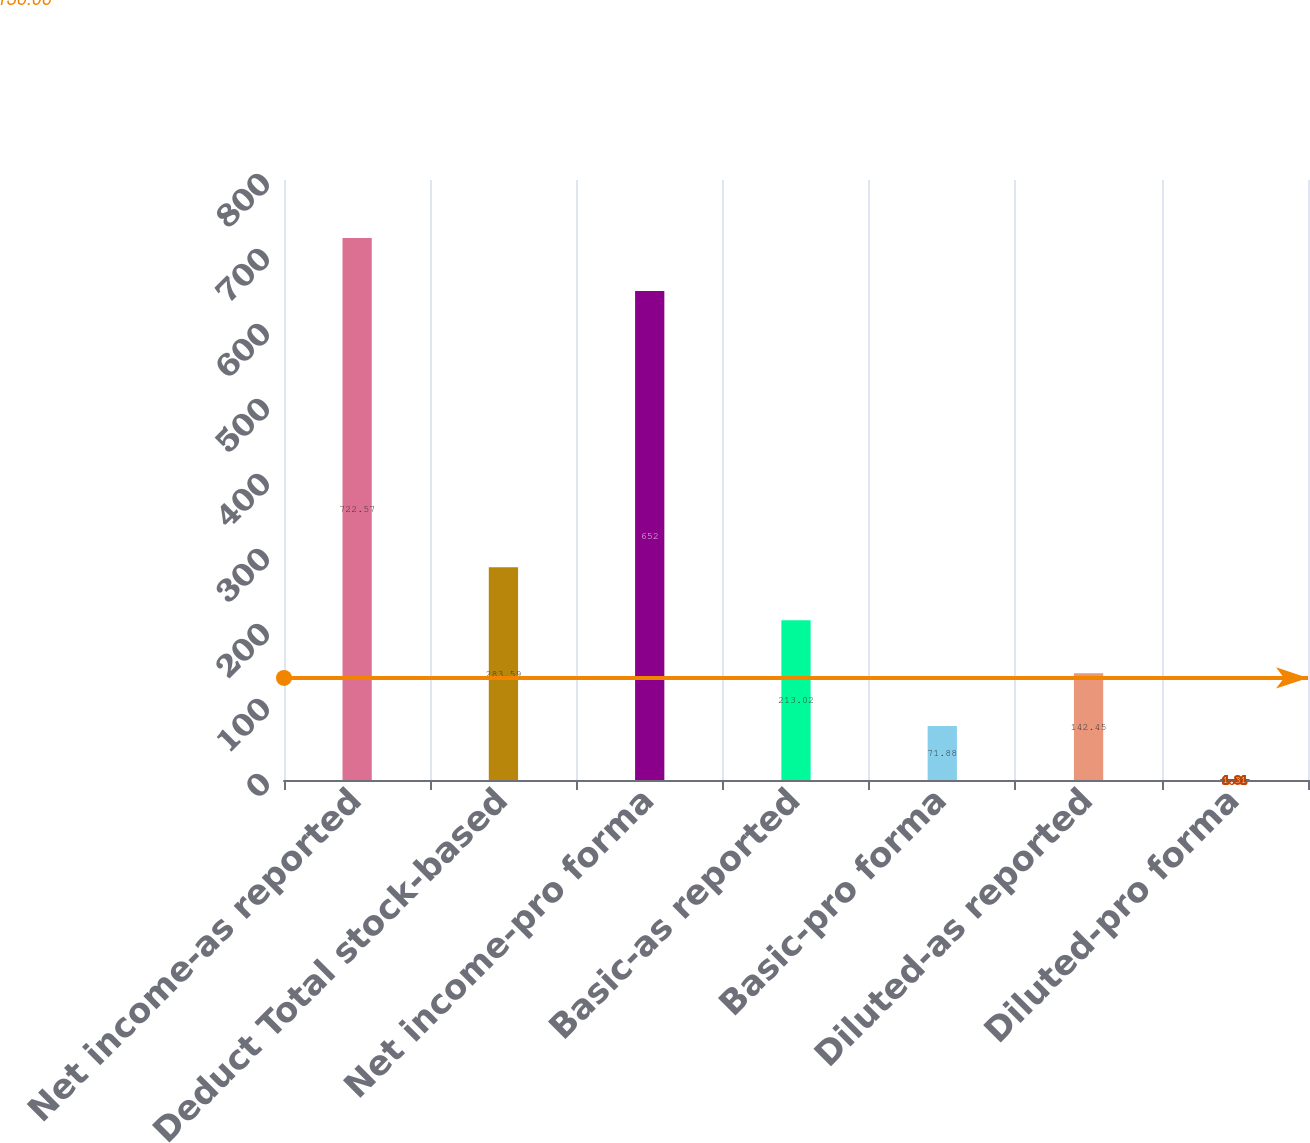Convert chart. <chart><loc_0><loc_0><loc_500><loc_500><bar_chart><fcel>Net income-as reported<fcel>Deduct Total stock-based<fcel>Net income-pro forma<fcel>Basic-as reported<fcel>Basic-pro forma<fcel>Diluted-as reported<fcel>Diluted-pro forma<nl><fcel>722.57<fcel>283.59<fcel>652<fcel>213.02<fcel>71.88<fcel>142.45<fcel>1.31<nl></chart> 